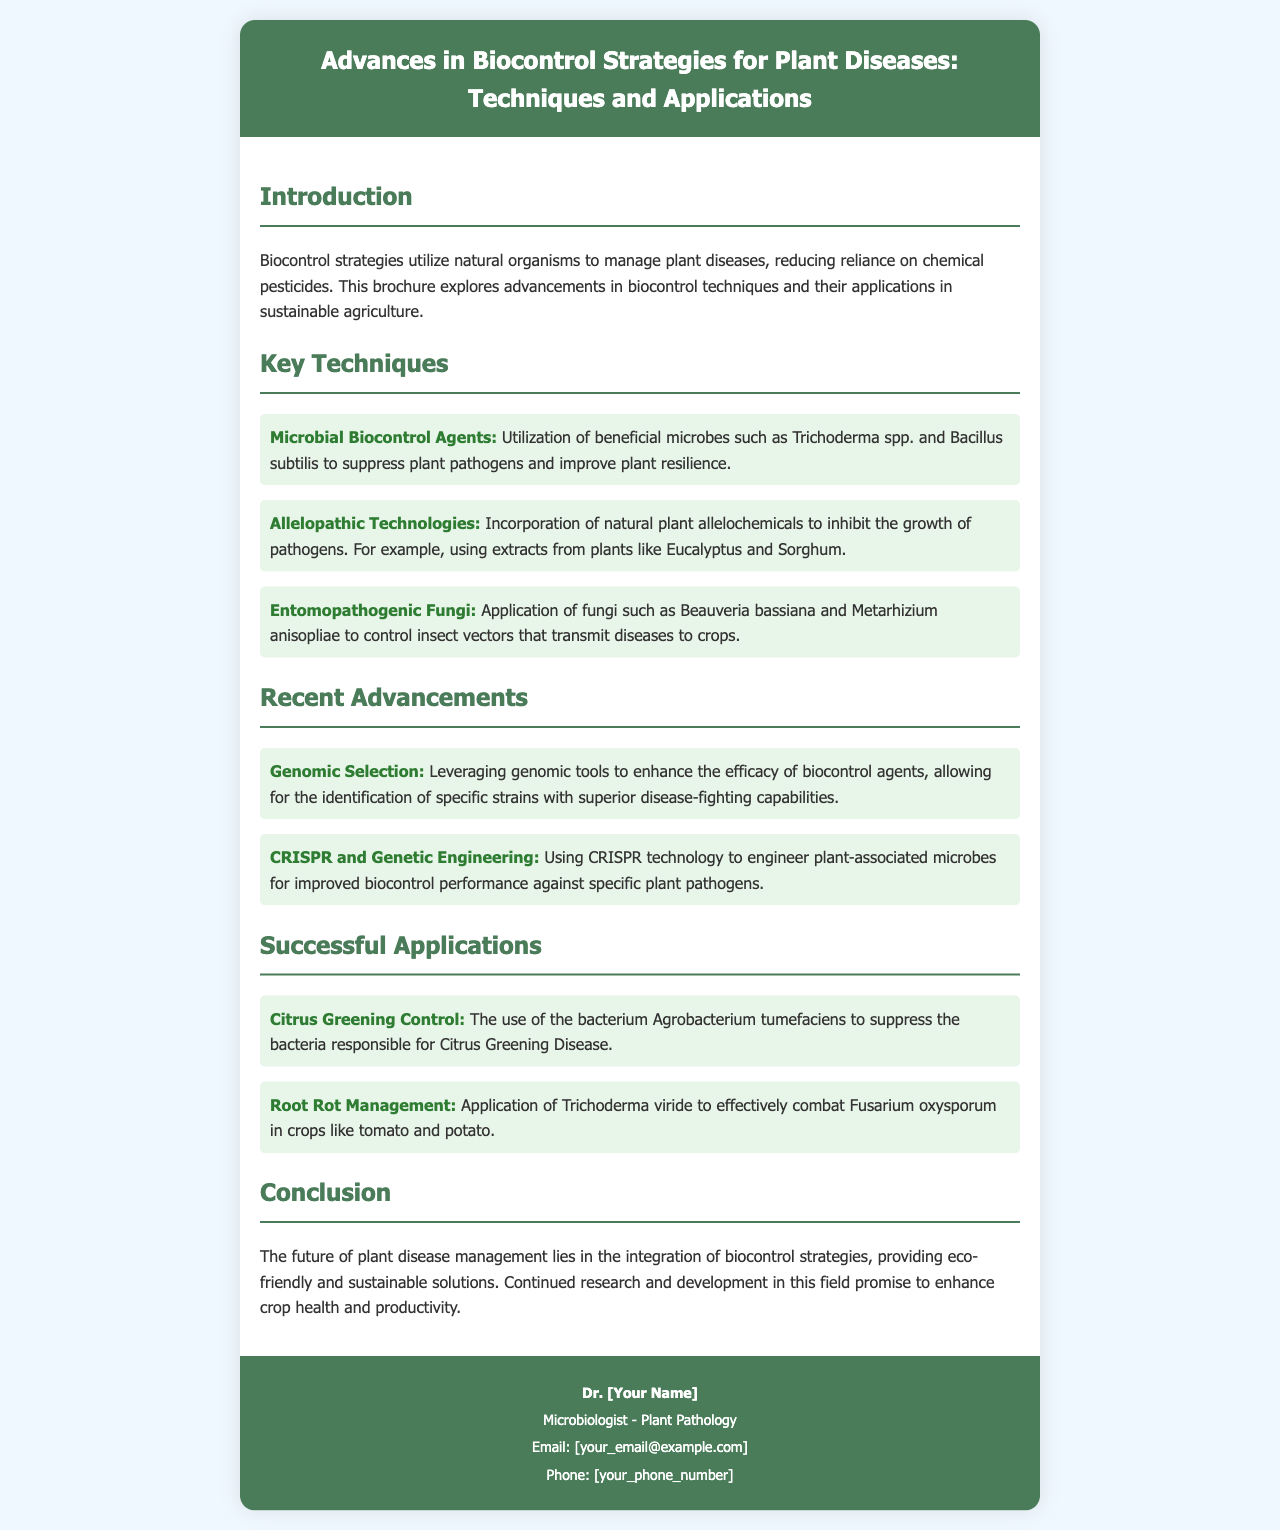What is the main focus of biocontrol strategies? The main focus of biocontrol strategies is to utilize natural organisms to manage plant diseases, reducing reliance on chemical pesticides.
Answer: Natural organisms Name one beneficial microbe mentioned in the brochure. The brochure mentions beneficial microbes such as Trichoderma spp. and Bacillus subtilis.
Answer: Trichoderma spp What technology is highlighted as a recent advancement? The brochure highlights CRISPR and genetic engineering as a recent advancement in biocontrol strategies.
Answer: CRISPR Which fungus is used for controlling insect vectors? The brochure states that Beauveria bassiana is an example of a fungus used to control insect vectors.
Answer: Beauveria bassiana What disease does Agrobacterium tumefaciens help to control? The brochure indicates that Agrobacterium tumefaciens is used to suppress the bacteria responsible for Citrus Greening Disease.
Answer: Citrus Greening Disease How does the brochure suggest improving the efficacy of biocontrol agents? The brochure suggests enhancing efficacy through genomic selection, allowing the identification of specific strains.
Answer: Genomic selection What is the role of allelopathic technologies? Allelopathic technologies involve incorporating natural plant allelochemicals to inhibit the growth of pathogens.
Answer: Inhibit growth of pathogens Who is the target audience for this brochure? The brochure is intended for individuals interested in sustainable agriculture and plant disease management.
Answer: Individuals interested in sustainable agriculture What is the purpose of the contact section? The contact section provides information for readers to reach out to the author for more details or inquiries.
Answer: Provide author contact information 